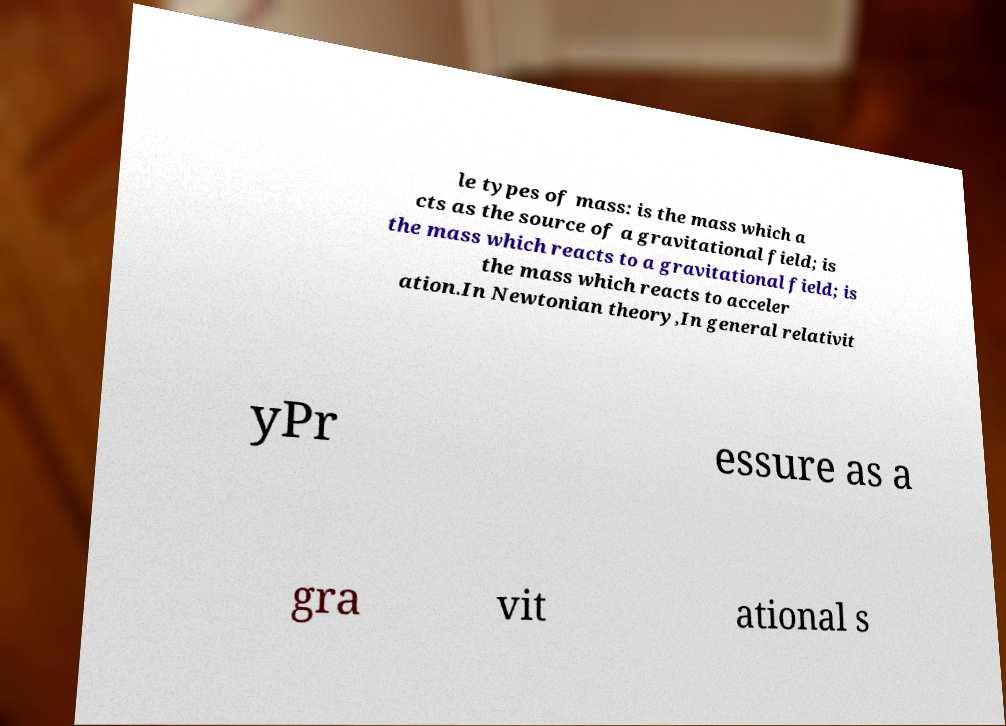For documentation purposes, I need the text within this image transcribed. Could you provide that? le types of mass: is the mass which a cts as the source of a gravitational field; is the mass which reacts to a gravitational field; is the mass which reacts to acceler ation.In Newtonian theory,In general relativit yPr essure as a gra vit ational s 